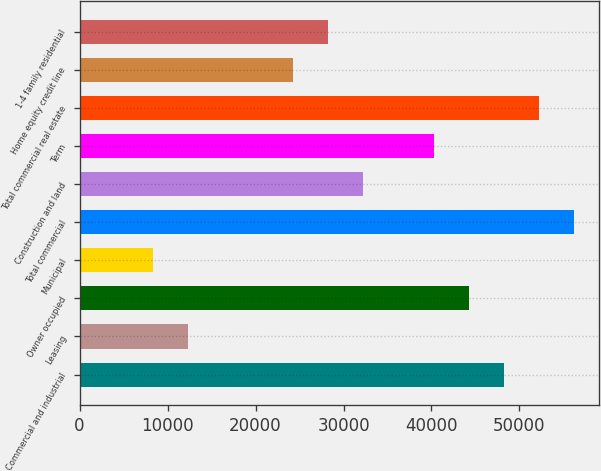Convert chart to OTSL. <chart><loc_0><loc_0><loc_500><loc_500><bar_chart><fcel>Commercial and industrial<fcel>Leasing<fcel>Owner occupied<fcel>Municipal<fcel>Total commercial<fcel>Construction and land<fcel>Term<fcel>Total commercial real estate<fcel>Home equity credit line<fcel>1-4 family residential<nl><fcel>48253.2<fcel>12283.8<fcel>44256.6<fcel>8287.2<fcel>56246.4<fcel>32266.8<fcel>40260<fcel>52249.8<fcel>24273.6<fcel>28270.2<nl></chart> 